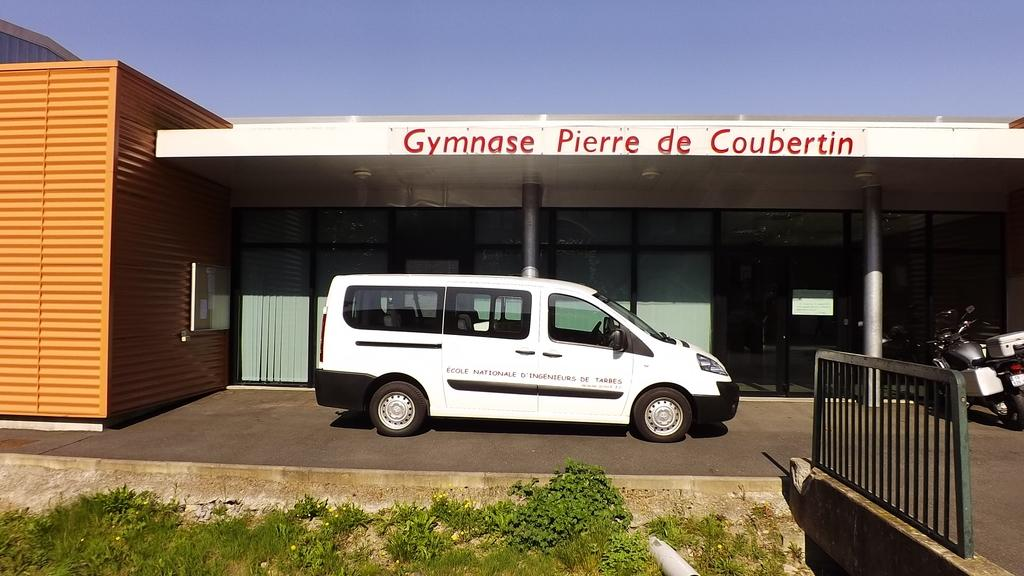<image>
Give a short and clear explanation of the subsequent image. A white van sits in front of Gymnase Pierre de Coubertin. 